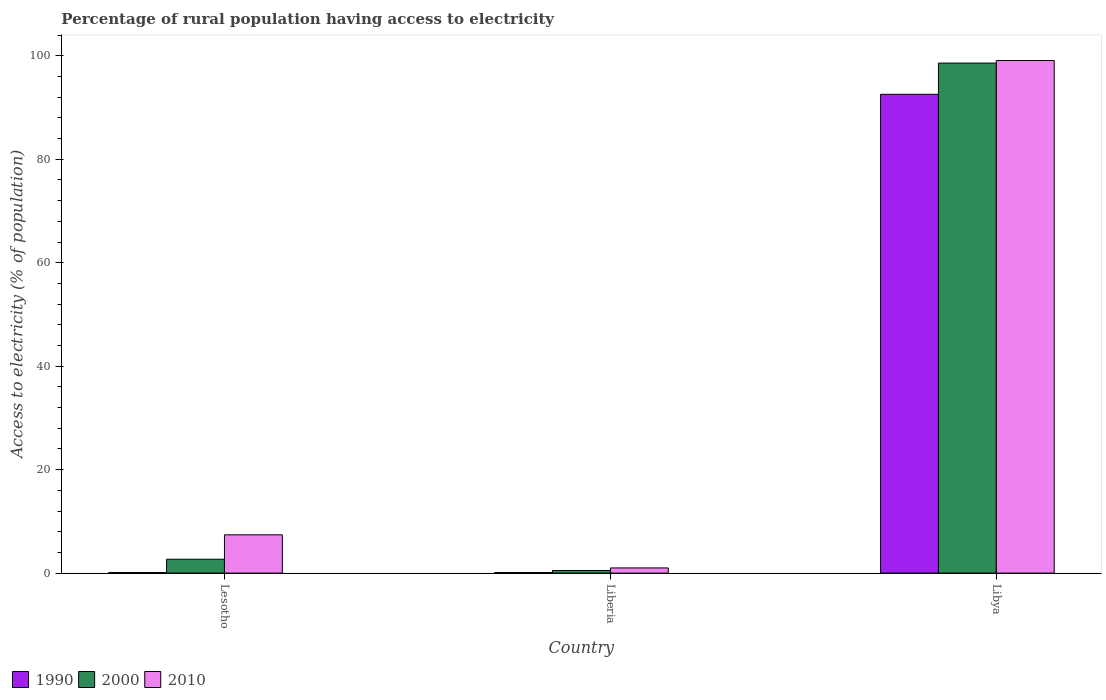How many different coloured bars are there?
Your answer should be very brief. 3. How many groups of bars are there?
Provide a succinct answer. 3. How many bars are there on the 2nd tick from the right?
Your answer should be very brief. 3. What is the label of the 3rd group of bars from the left?
Make the answer very short. Libya. In how many cases, is the number of bars for a given country not equal to the number of legend labels?
Ensure brevity in your answer.  0. What is the percentage of rural population having access to electricity in 1990 in Libya?
Ensure brevity in your answer.  92.57. Across all countries, what is the maximum percentage of rural population having access to electricity in 2010?
Provide a short and direct response. 99.1. Across all countries, what is the minimum percentage of rural population having access to electricity in 2010?
Provide a succinct answer. 1. In which country was the percentage of rural population having access to electricity in 2000 maximum?
Your answer should be compact. Libya. In which country was the percentage of rural population having access to electricity in 2010 minimum?
Your answer should be very brief. Liberia. What is the total percentage of rural population having access to electricity in 1990 in the graph?
Offer a terse response. 92.77. What is the difference between the percentage of rural population having access to electricity in 2000 in Liberia and that in Libya?
Your answer should be very brief. -98.1. What is the difference between the percentage of rural population having access to electricity in 2010 in Liberia and the percentage of rural population having access to electricity in 2000 in Lesotho?
Provide a short and direct response. -1.68. What is the average percentage of rural population having access to electricity in 2000 per country?
Make the answer very short. 33.93. What is the difference between the percentage of rural population having access to electricity of/in 2000 and percentage of rural population having access to electricity of/in 1990 in Liberia?
Offer a very short reply. 0.4. In how many countries, is the percentage of rural population having access to electricity in 1990 greater than 44 %?
Your response must be concise. 1. What is the ratio of the percentage of rural population having access to electricity in 1990 in Lesotho to that in Libya?
Provide a short and direct response. 0. Is the difference between the percentage of rural population having access to electricity in 2000 in Lesotho and Libya greater than the difference between the percentage of rural population having access to electricity in 1990 in Lesotho and Libya?
Your response must be concise. No. What is the difference between the highest and the second highest percentage of rural population having access to electricity in 2010?
Offer a very short reply. -98.1. What is the difference between the highest and the lowest percentage of rural population having access to electricity in 1990?
Your response must be concise. 92.47. Is the sum of the percentage of rural population having access to electricity in 2000 in Lesotho and Libya greater than the maximum percentage of rural population having access to electricity in 2010 across all countries?
Offer a very short reply. Yes. What does the 3rd bar from the left in Liberia represents?
Offer a terse response. 2010. How many bars are there?
Your answer should be compact. 9. Does the graph contain grids?
Offer a terse response. No. Where does the legend appear in the graph?
Ensure brevity in your answer.  Bottom left. How many legend labels are there?
Ensure brevity in your answer.  3. What is the title of the graph?
Give a very brief answer. Percentage of rural population having access to electricity. Does "2008" appear as one of the legend labels in the graph?
Offer a terse response. No. What is the label or title of the X-axis?
Offer a very short reply. Country. What is the label or title of the Y-axis?
Offer a terse response. Access to electricity (% of population). What is the Access to electricity (% of population) of 1990 in Lesotho?
Ensure brevity in your answer.  0.1. What is the Access to electricity (% of population) in 2000 in Lesotho?
Your response must be concise. 2.68. What is the Access to electricity (% of population) of 2010 in Lesotho?
Give a very brief answer. 7.4. What is the Access to electricity (% of population) in 2010 in Liberia?
Offer a very short reply. 1. What is the Access to electricity (% of population) in 1990 in Libya?
Your answer should be compact. 92.57. What is the Access to electricity (% of population) of 2000 in Libya?
Offer a terse response. 98.6. What is the Access to electricity (% of population) in 2010 in Libya?
Your answer should be very brief. 99.1. Across all countries, what is the maximum Access to electricity (% of population) of 1990?
Provide a succinct answer. 92.57. Across all countries, what is the maximum Access to electricity (% of population) of 2000?
Provide a succinct answer. 98.6. Across all countries, what is the maximum Access to electricity (% of population) of 2010?
Provide a succinct answer. 99.1. Across all countries, what is the minimum Access to electricity (% of population) of 1990?
Offer a terse response. 0.1. What is the total Access to electricity (% of population) in 1990 in the graph?
Make the answer very short. 92.77. What is the total Access to electricity (% of population) in 2000 in the graph?
Offer a very short reply. 101.78. What is the total Access to electricity (% of population) in 2010 in the graph?
Your answer should be very brief. 107.5. What is the difference between the Access to electricity (% of population) in 2000 in Lesotho and that in Liberia?
Provide a short and direct response. 2.18. What is the difference between the Access to electricity (% of population) in 2010 in Lesotho and that in Liberia?
Keep it short and to the point. 6.4. What is the difference between the Access to electricity (% of population) in 1990 in Lesotho and that in Libya?
Your answer should be very brief. -92.47. What is the difference between the Access to electricity (% of population) in 2000 in Lesotho and that in Libya?
Offer a terse response. -95.92. What is the difference between the Access to electricity (% of population) of 2010 in Lesotho and that in Libya?
Give a very brief answer. -91.7. What is the difference between the Access to electricity (% of population) of 1990 in Liberia and that in Libya?
Ensure brevity in your answer.  -92.47. What is the difference between the Access to electricity (% of population) of 2000 in Liberia and that in Libya?
Your answer should be compact. -98.1. What is the difference between the Access to electricity (% of population) of 2010 in Liberia and that in Libya?
Provide a short and direct response. -98.1. What is the difference between the Access to electricity (% of population) in 2000 in Lesotho and the Access to electricity (% of population) in 2010 in Liberia?
Keep it short and to the point. 1.68. What is the difference between the Access to electricity (% of population) in 1990 in Lesotho and the Access to electricity (% of population) in 2000 in Libya?
Keep it short and to the point. -98.5. What is the difference between the Access to electricity (% of population) of 1990 in Lesotho and the Access to electricity (% of population) of 2010 in Libya?
Provide a short and direct response. -99. What is the difference between the Access to electricity (% of population) in 2000 in Lesotho and the Access to electricity (% of population) in 2010 in Libya?
Make the answer very short. -96.42. What is the difference between the Access to electricity (% of population) in 1990 in Liberia and the Access to electricity (% of population) in 2000 in Libya?
Your answer should be very brief. -98.5. What is the difference between the Access to electricity (% of population) of 1990 in Liberia and the Access to electricity (% of population) of 2010 in Libya?
Your answer should be very brief. -99. What is the difference between the Access to electricity (% of population) of 2000 in Liberia and the Access to electricity (% of population) of 2010 in Libya?
Provide a short and direct response. -98.6. What is the average Access to electricity (% of population) in 1990 per country?
Provide a succinct answer. 30.92. What is the average Access to electricity (% of population) of 2000 per country?
Provide a short and direct response. 33.93. What is the average Access to electricity (% of population) of 2010 per country?
Offer a terse response. 35.83. What is the difference between the Access to electricity (% of population) in 1990 and Access to electricity (% of population) in 2000 in Lesotho?
Offer a very short reply. -2.58. What is the difference between the Access to electricity (% of population) of 2000 and Access to electricity (% of population) of 2010 in Lesotho?
Provide a succinct answer. -4.72. What is the difference between the Access to electricity (% of population) of 2000 and Access to electricity (% of population) of 2010 in Liberia?
Make the answer very short. -0.5. What is the difference between the Access to electricity (% of population) in 1990 and Access to electricity (% of population) in 2000 in Libya?
Offer a very short reply. -6.03. What is the difference between the Access to electricity (% of population) in 1990 and Access to electricity (% of population) in 2010 in Libya?
Provide a short and direct response. -6.53. What is the ratio of the Access to electricity (% of population) of 1990 in Lesotho to that in Liberia?
Give a very brief answer. 1. What is the ratio of the Access to electricity (% of population) in 2000 in Lesotho to that in Liberia?
Give a very brief answer. 5.36. What is the ratio of the Access to electricity (% of population) in 1990 in Lesotho to that in Libya?
Your response must be concise. 0. What is the ratio of the Access to electricity (% of population) in 2000 in Lesotho to that in Libya?
Give a very brief answer. 0.03. What is the ratio of the Access to electricity (% of population) of 2010 in Lesotho to that in Libya?
Make the answer very short. 0.07. What is the ratio of the Access to electricity (% of population) in 1990 in Liberia to that in Libya?
Your response must be concise. 0. What is the ratio of the Access to electricity (% of population) of 2000 in Liberia to that in Libya?
Offer a terse response. 0.01. What is the ratio of the Access to electricity (% of population) in 2010 in Liberia to that in Libya?
Your answer should be compact. 0.01. What is the difference between the highest and the second highest Access to electricity (% of population) of 1990?
Offer a terse response. 92.47. What is the difference between the highest and the second highest Access to electricity (% of population) in 2000?
Provide a short and direct response. 95.92. What is the difference between the highest and the second highest Access to electricity (% of population) of 2010?
Offer a very short reply. 91.7. What is the difference between the highest and the lowest Access to electricity (% of population) in 1990?
Offer a very short reply. 92.47. What is the difference between the highest and the lowest Access to electricity (% of population) in 2000?
Your answer should be very brief. 98.1. What is the difference between the highest and the lowest Access to electricity (% of population) of 2010?
Provide a short and direct response. 98.1. 